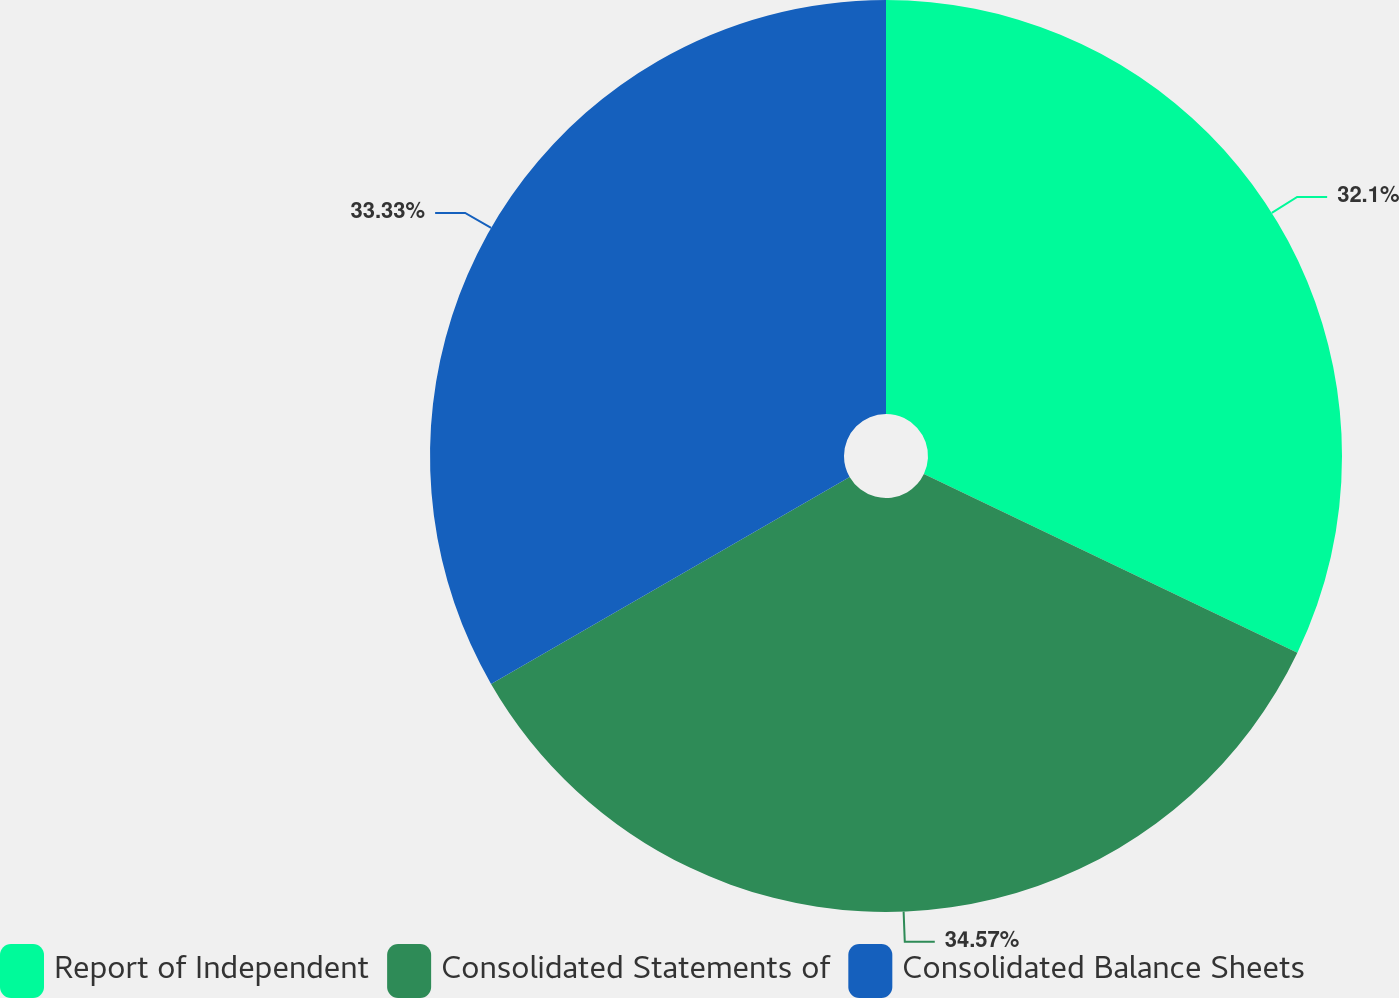Convert chart to OTSL. <chart><loc_0><loc_0><loc_500><loc_500><pie_chart><fcel>Report of Independent<fcel>Consolidated Statements of<fcel>Consolidated Balance Sheets<nl><fcel>32.1%<fcel>34.57%<fcel>33.33%<nl></chart> 